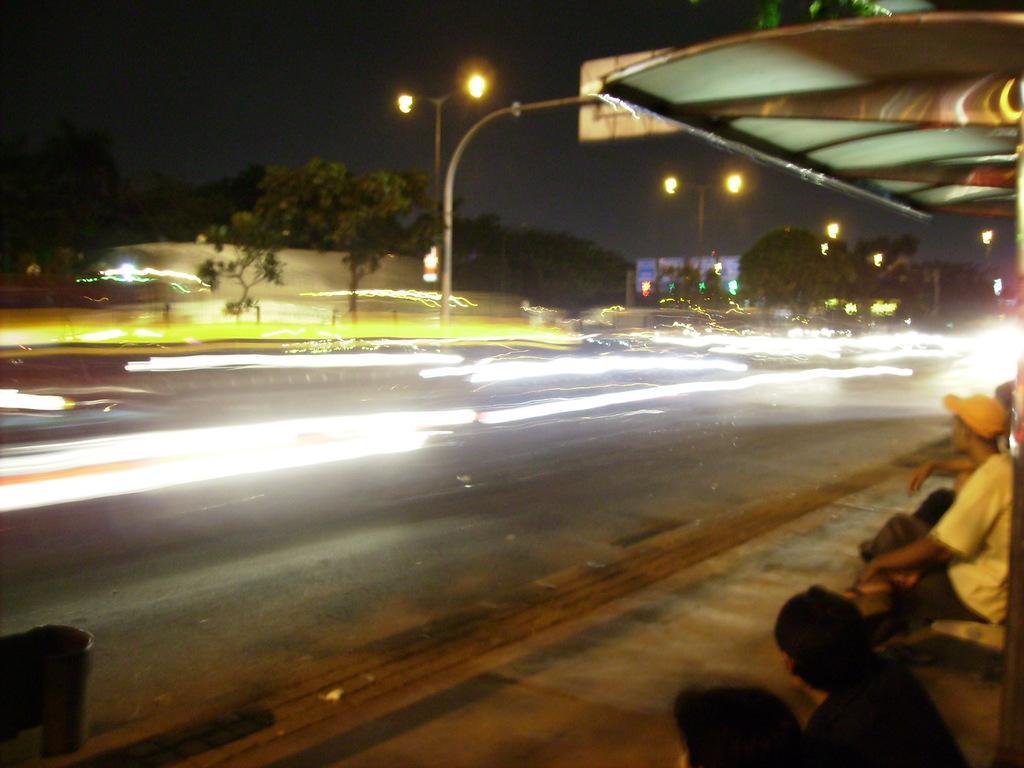How would you summarize this image in a sentence or two? On the bottom right we can see group of persons sitting on the bench. Here we can see a shed. On the road we can see many vehicles. In the back we can see advertisement board, traffic signals, street lights and wall. On the top there is a sky. 